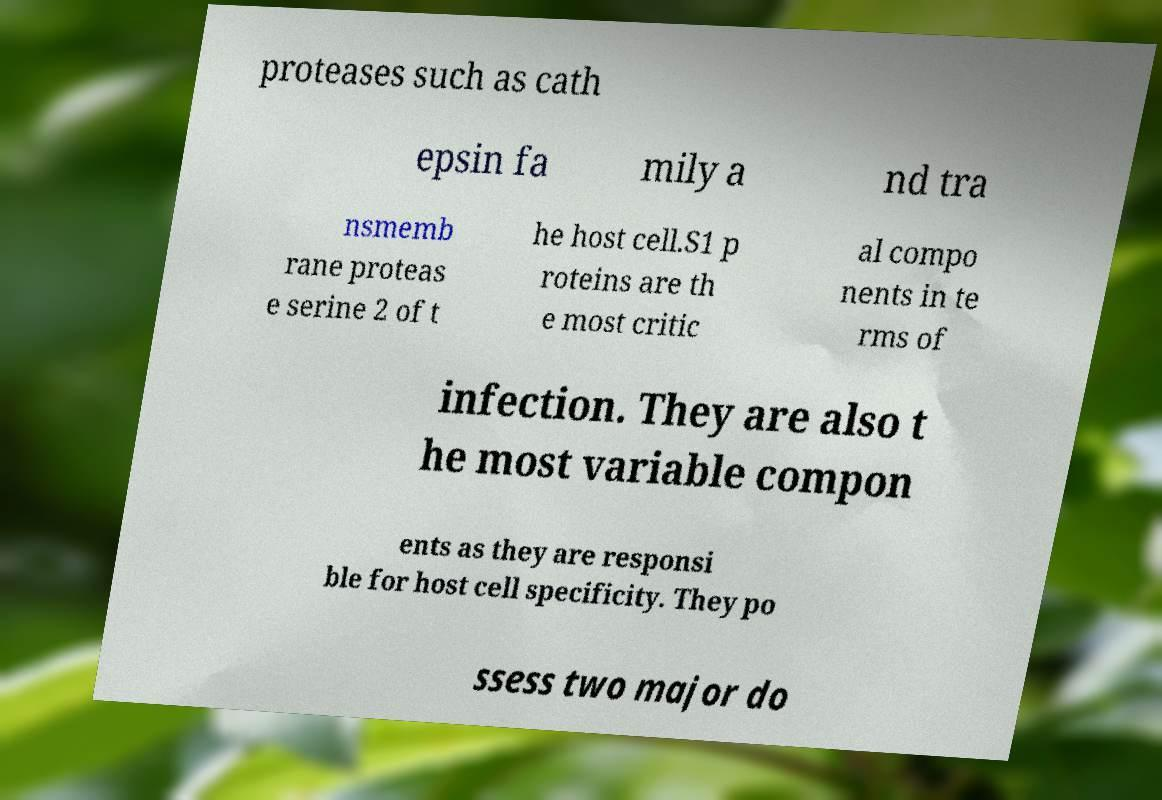Please identify and transcribe the text found in this image. proteases such as cath epsin fa mily a nd tra nsmemb rane proteas e serine 2 of t he host cell.S1 p roteins are th e most critic al compo nents in te rms of infection. They are also t he most variable compon ents as they are responsi ble for host cell specificity. They po ssess two major do 